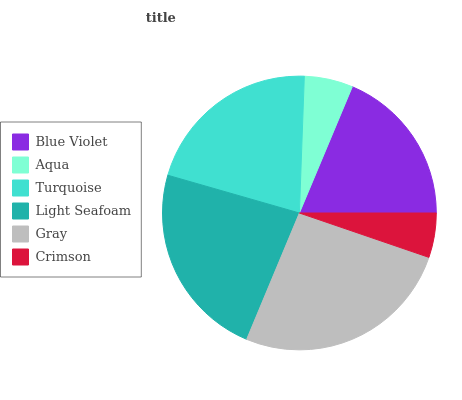Is Crimson the minimum?
Answer yes or no. Yes. Is Gray the maximum?
Answer yes or no. Yes. Is Aqua the minimum?
Answer yes or no. No. Is Aqua the maximum?
Answer yes or no. No. Is Blue Violet greater than Aqua?
Answer yes or no. Yes. Is Aqua less than Blue Violet?
Answer yes or no. Yes. Is Aqua greater than Blue Violet?
Answer yes or no. No. Is Blue Violet less than Aqua?
Answer yes or no. No. Is Turquoise the high median?
Answer yes or no. Yes. Is Blue Violet the low median?
Answer yes or no. Yes. Is Aqua the high median?
Answer yes or no. No. Is Light Seafoam the low median?
Answer yes or no. No. 